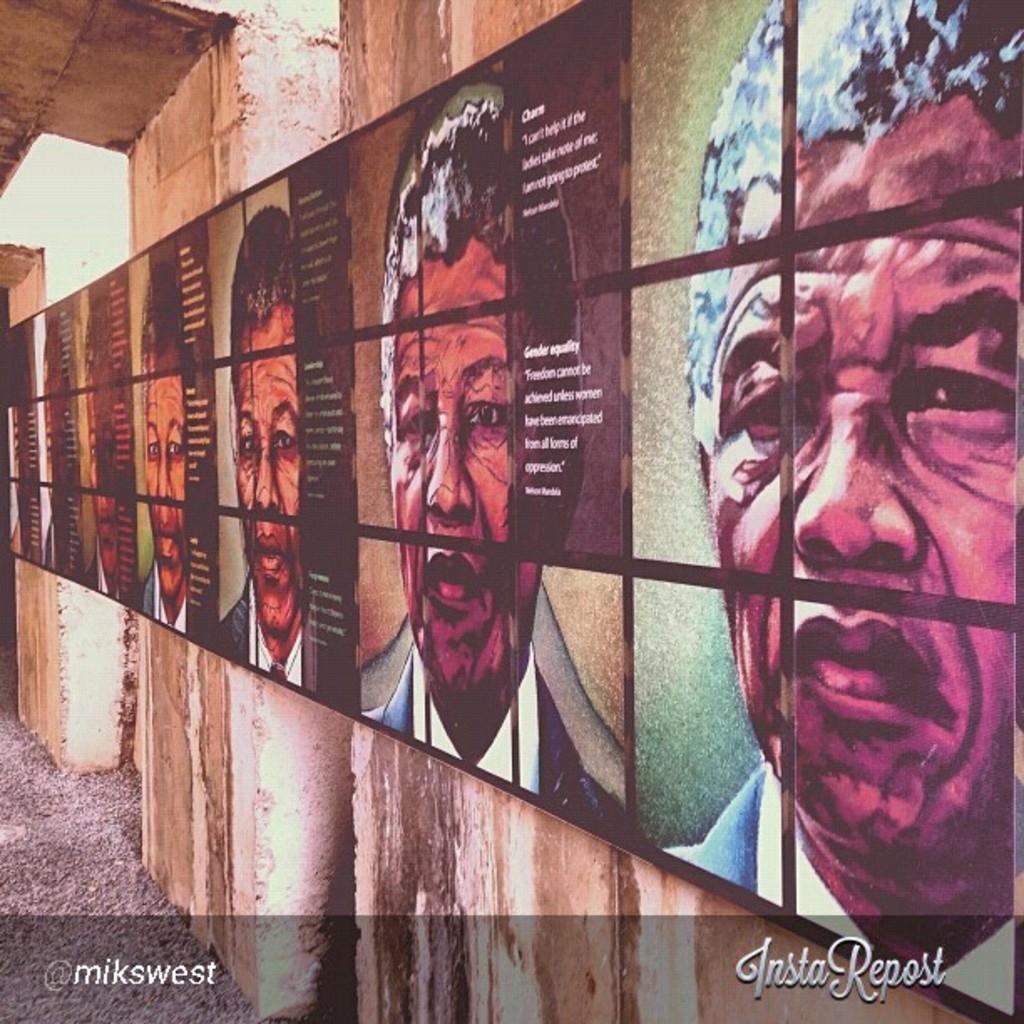Describe this image in one or two sentences. In the picture there are a lot of pictures of few people and some information containing board is attached to the walls combinedly. 